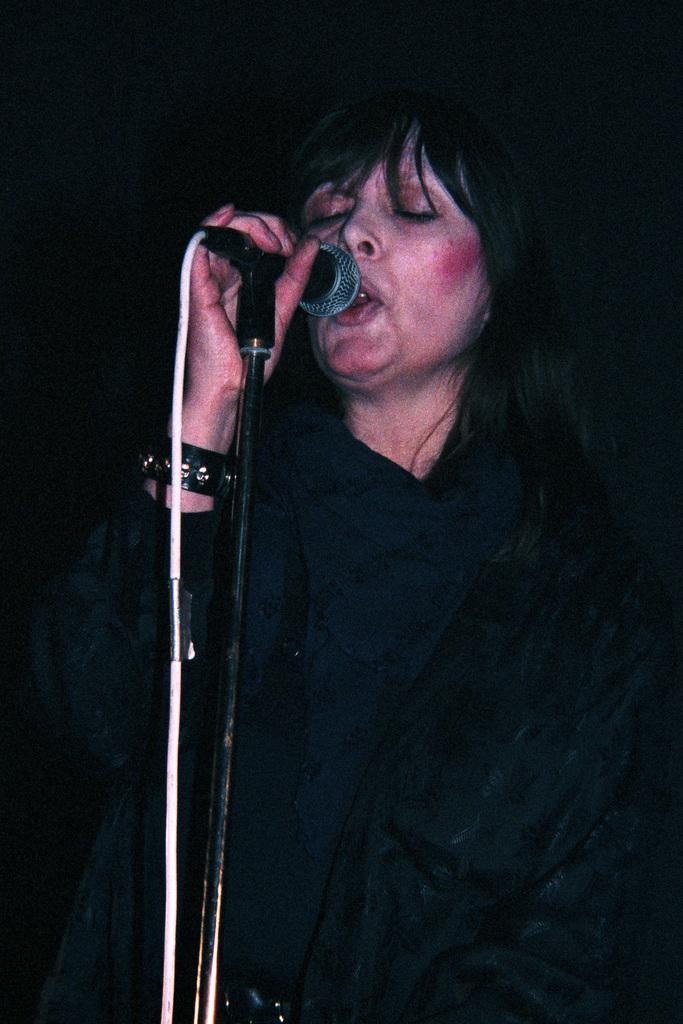Describe this image in one or two sentences. In this image I can see the person is standing and wearing black color dress and holding the mic. The mic is on the stand. 